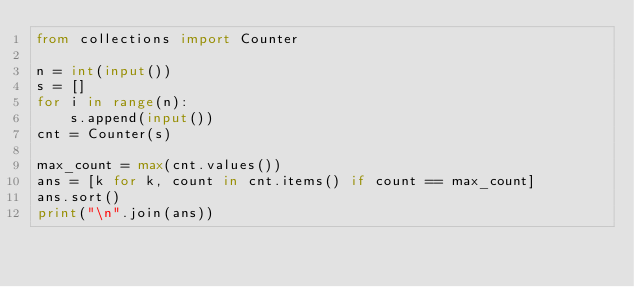<code> <loc_0><loc_0><loc_500><loc_500><_Python_>from collections import Counter

n = int(input())
s = []
for i in range(n):
    s.append(input())
cnt = Counter(s)

max_count = max(cnt.values())
ans = [k for k, count in cnt.items() if count == max_count]
ans.sort()
print("\n".join(ans))
</code> 